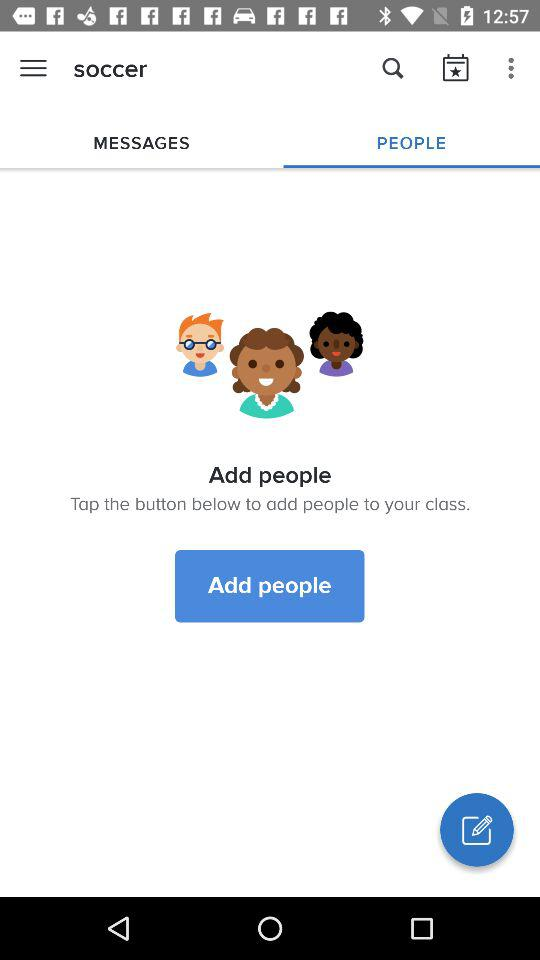Which tab am I using? You are using the "PEOPLE" tab. 